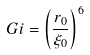Convert formula to latex. <formula><loc_0><loc_0><loc_500><loc_500>G i = \left ( \frac { r _ { 0 } } { \xi _ { 0 } } \right ) ^ { 6 } \,</formula> 